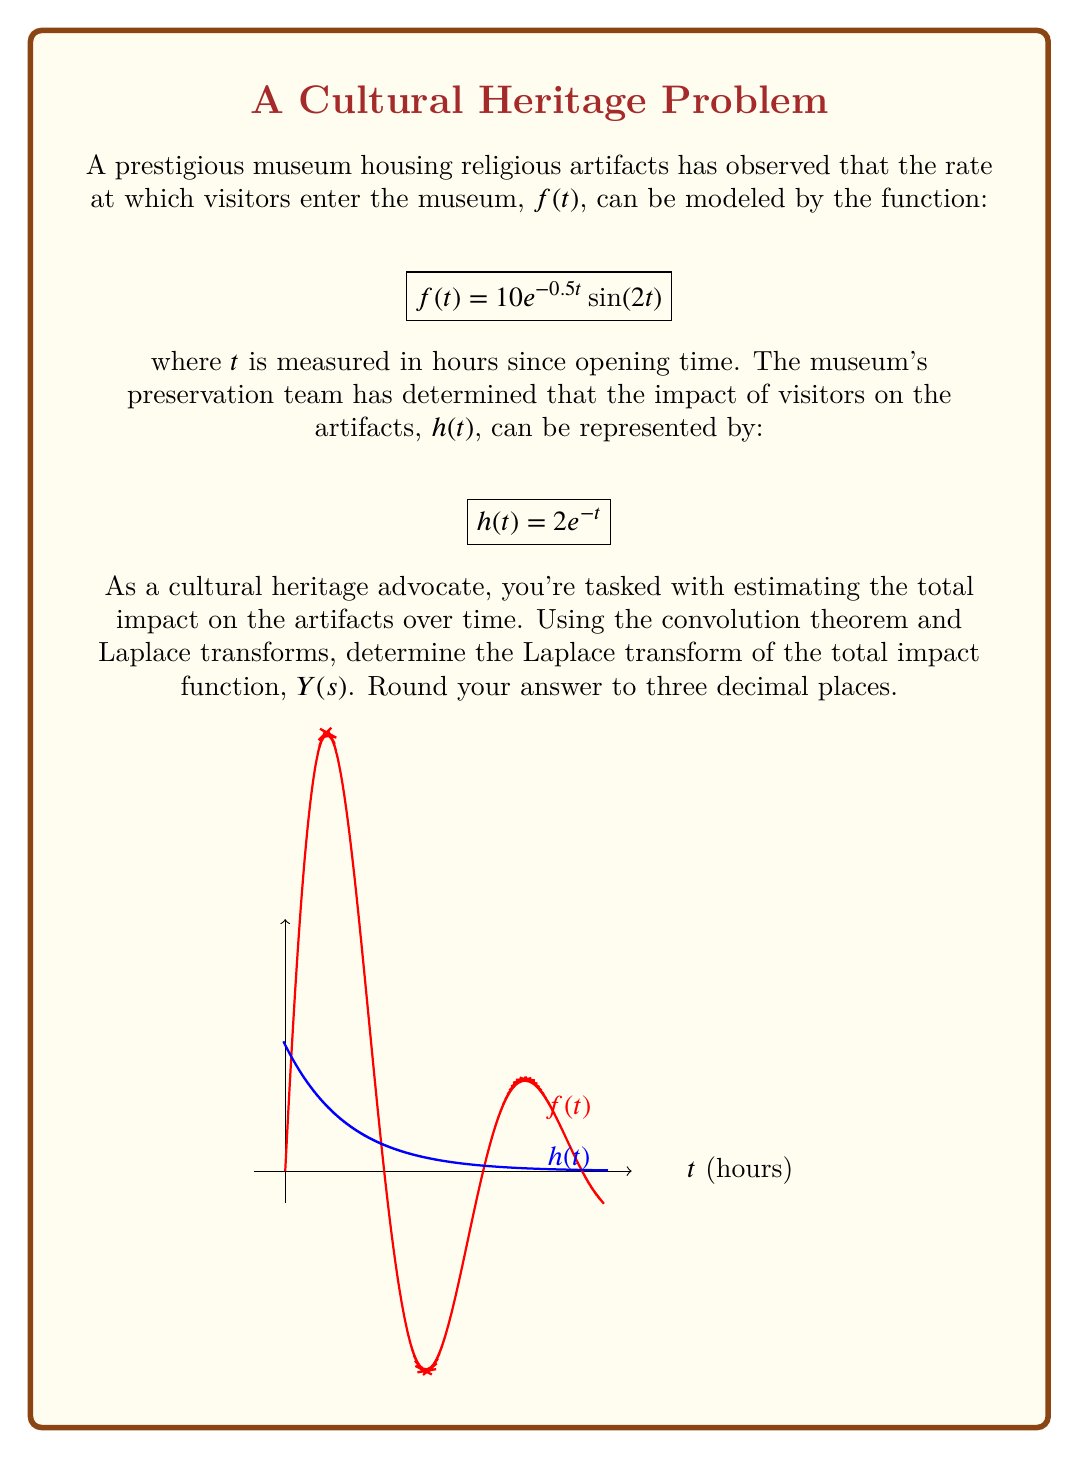Give your solution to this math problem. Let's approach this step-by-step using the convolution theorem and Laplace transforms:

1) The convolution theorem states that the Laplace transform of the convolution of two functions is equal to the product of their individual Laplace transforms:

   $$\mathcal{L}\{f(t) * h(t)\} = F(s) \cdot H(s)$$

2) We need to find $F(s)$ and $H(s)$ separately, then multiply them.

3) For $H(s)$:
   $$H(s) = \mathcal{L}\{2e^{-t}\} = \frac{2}{s+1}$$

4) For $F(s)$, we use the Laplace transform of $e^{at}\sin(bt)$:
   $$\mathcal{L}\{e^{at}\sin(bt)\} = \frac{b}{(s-a)^2 + b^2}$$

   In our case, $a=-0.5$ and $b=2$. Also, we have a factor of 10:

   $$F(s) = \mathcal{L}\{10e^{-0.5t}\sin(2t)\} = \frac{20}{(s+0.5)^2 + 4}$$

5) Now, we multiply $F(s)$ and $H(s)$:

   $$Y(s) = F(s) \cdot H(s) = \frac{20}{(s+0.5)^2 + 4} \cdot \frac{2}{s+1}$$

6) Simplifying:

   $$Y(s) = \frac{40}{((s+0.5)^2 + 4)(s+1)}$$

7) Rounding to three decimal places:

   $$Y(s) \approx \frac{40.000}{(s^2 + s + 4.250)(s + 1.000)}$$
Answer: $$Y(s) \approx \frac{40.000}{(s^2 + s + 4.250)(s + 1.000)}$$ 